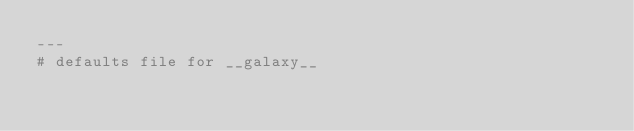<code> <loc_0><loc_0><loc_500><loc_500><_YAML_>---
# defaults file for __galaxy__
</code> 